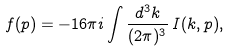<formula> <loc_0><loc_0><loc_500><loc_500>f ( p ) = - 1 6 \pi i \int \frac { d ^ { 3 } k } { ( 2 \pi ) ^ { 3 } } \, I ( k , p ) ,</formula> 